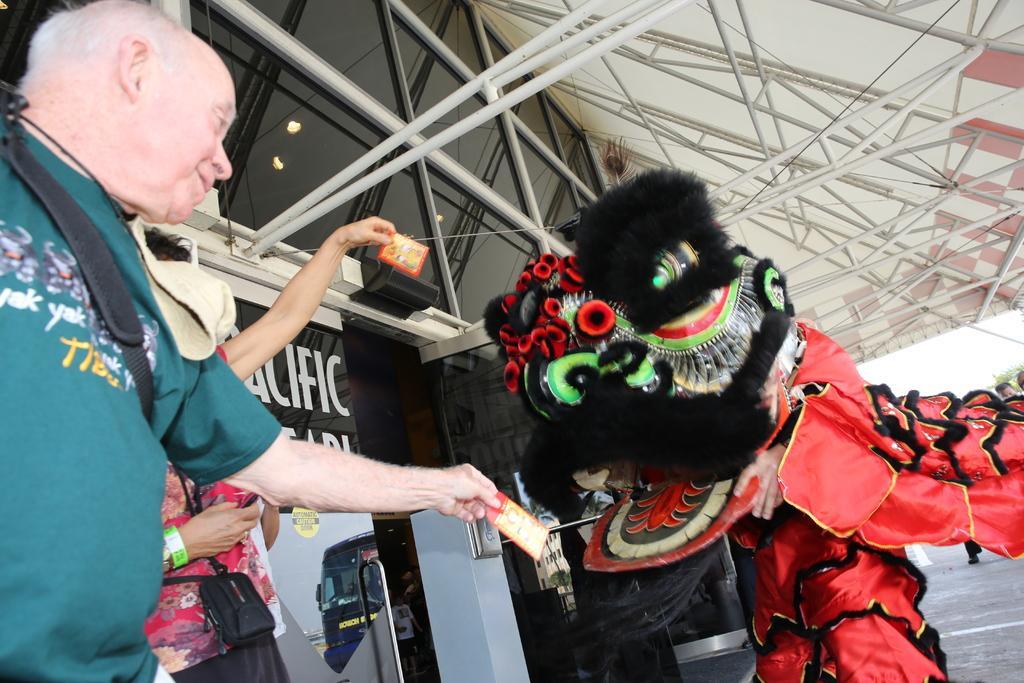Describe this image in one or two sentences. On the left side of the image we can see two persons are standing and holding a card in their hands. On the right side of the image we can see a person wearing different type of dress which is red and black in color. 